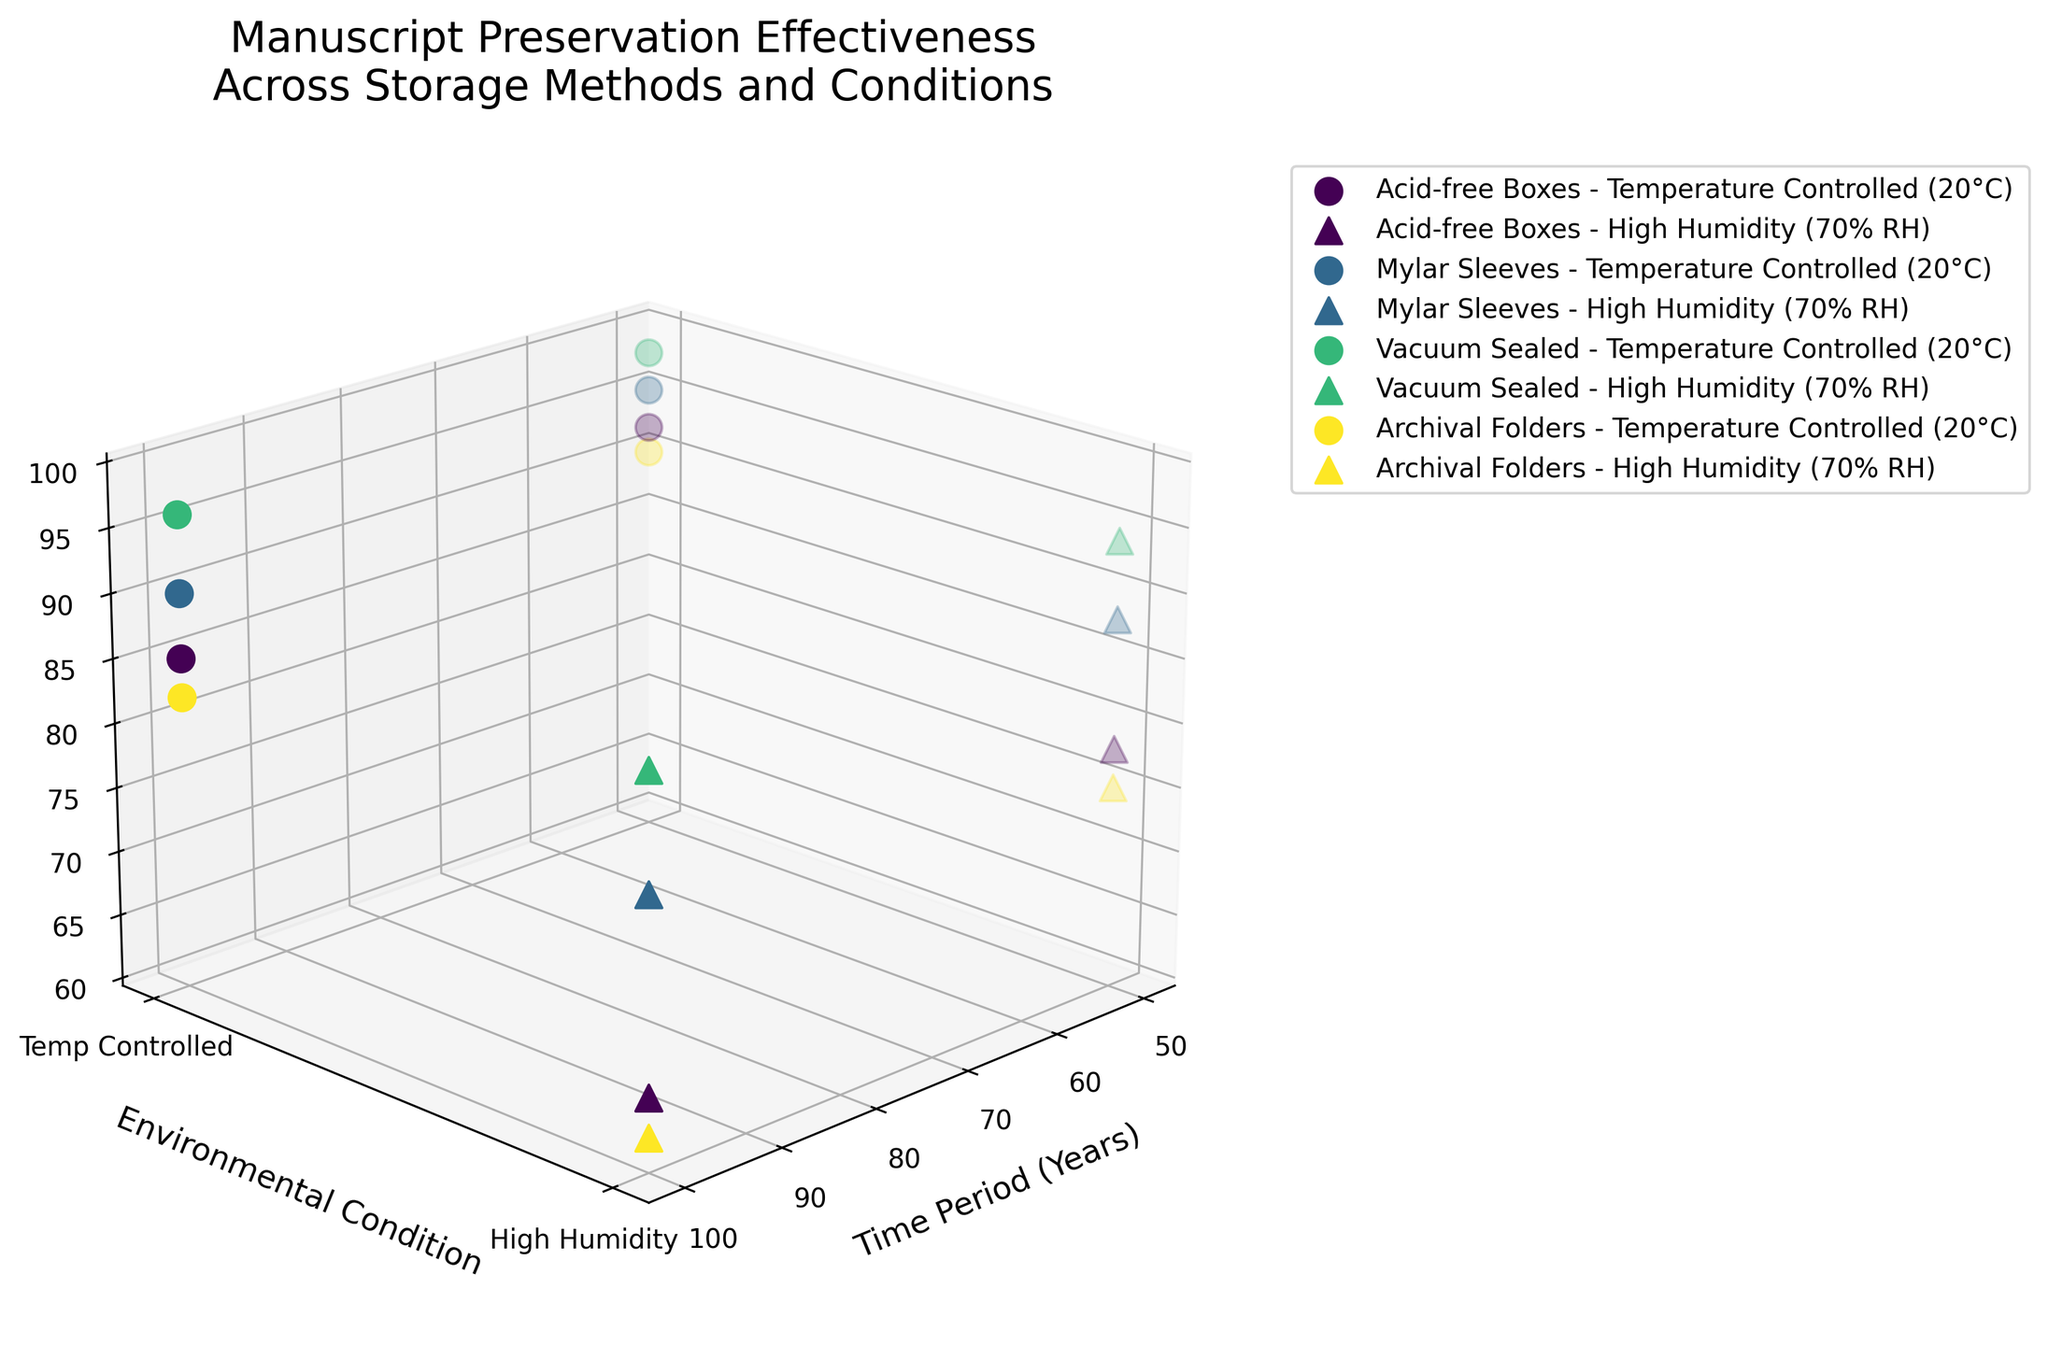Which storage method shows the highest preservation effectiveness after 50 years under temperature-controlled conditions? By identifying the data points that represent "50 years" and "Temperature Controlled (20°C)" on the x and y axes, and looking for the highest z-value, we see that Vacuum Sealed (98%) is the highest.
Answer: Vacuum Sealed Which combination of storage method and environmental condition has the lowest preservation effectiveness after 100 years? By looking at the data points for 100 years, we identify that "Archival Folders" under "High Humidity (70% RH)" shows the lowest z-value at 62%.
Answer: Archival Folders - High Humidity (70% RH) How does the preservation effectiveness of Acid-free Boxes change from 50 to 100 years under high humidity? The effectiveness at 50 years under high humidity is 78%, and it drops to 65% at 100 years. This can be calculated by finding the difference, which is 78 - 65 = 13%.
Answer: Decreases by 13% Comparing Mylar Sleeves and Vacuum Sealed under high humidity for 100 years, which method is more effective? For the 100-year period under high humidity, Mylar Sleeves have an effectiveness of 80%, while Vacuum Sealed has 89%. Therefore, Vacuum Sealed is more effective.
Answer: Vacuum Sealed What is the overall trend for preservation effectiveness over time across all methods and conditions? Observing the data points as a whole, preservation effectiveness tends to decrease over time for all methods and conditions.
Answer: Decreases Which environmental condition consistently shows higher preservation effectiveness for all storage methods? For each storage method, comparing data points between "Temperature Controlled (20°C)" and "High Humidity (70% RH)", the temperature-controlled condition consistently shows higher preservation percentages.
Answer: Temperature Controlled (20°C) How do the preservation effectiveness values of Archival Folders compare with Acid-free Boxes after 100 years under temperature-controlled conditions? For the 100-year period under temperature-controlled conditions, Archival Folders have 82% effectiveness, and Acid-free Boxes have 85%. Hence, Acid-free Boxes are marginally more effective.
Answer: Acid-free Boxes Between Mylar Sleeves and Acid-free Boxes, which shows a faster rate of decrease in effectiveness under high humidity? For Mylar Sleeves under high humidity, effectiveness decreases from 88% to 80% (a drop of 8%), and for Acid-free Boxes, it drops from 78% to 65% (a drop of 13%). Therefore, Acid-free Boxes show a faster rate of decrease.
Answer: Acid-free Boxes 